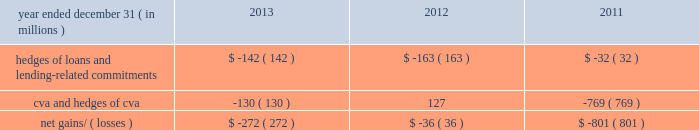Management 2019s discussion and analysis 138 jpmorgan chase & co./2013 annual report the credit derivatives used in credit portfolio management activities do not qualify for hedge accounting under u.s .
Gaap ; these derivatives are reported at fair value , with gains and losses recognized in principal transactions revenue .
In contrast , the loans and lending-related commitments being risk-managed are accounted for on an accrual basis .
This asymmetry in accounting treatment , between loans and lending-related commitments and the credit derivatives used in credit portfolio management activities , causes earnings volatility that is not representative , in the firm 2019s view , of the true changes in value of the firm 2019s overall credit exposure .
The effectiveness of the firm 2019s credit default swap ( 201ccds 201d ) protection as a hedge of the firm 2019s exposures may vary depending on a number of factors , including the named reference entity ( i.e. , the firm may experience losses on specific exposures that are different than the named reference entities in the purchased cds ) , and the contractual terms of the cds ( which may have a defined credit event that does not align with an actual loss realized by the firm ) and the maturity of the firm 2019s cds protection ( which in some cases may be shorter than the firm 2019s exposures ) .
However , the firm generally seeks to purchase credit protection with a maturity date that is the same or similar to the maturity date of the exposure for which the protection was purchased , and remaining differences in maturity are actively monitored and managed by the firm .
Credit portfolio hedges the table sets out the fair value related to the firm 2019s credit derivatives used in credit portfolio management activities , the fair value related to the cva ( which reflects the credit quality of derivatives counterparty exposure ) , as well as certain other hedges used in the risk management of cva .
These results can vary from period-to- period due to market conditions that affect specific positions in the portfolio .
Net gains and losses on credit portfolio hedges year ended december 31 , ( in millions ) 2013 2012 2011 hedges of loans and lending- related commitments $ ( 142 ) $ ( 163 ) $ ( 32 ) .
Community reinvestment act exposure the community reinvestment act ( 201ccra 201d ) encourages banks to meet the credit needs of borrowers in all segments of their communities , including neighborhoods with low or moderate incomes .
The firm is a national leader in community development by providing loans , investments and community development services in communities across the united states .
At december 31 , 2013 and 2012 , the firm 2019s cra loan portfolio was approximately $ 18 billion and $ 16 billion , respectively .
At december 31 , 2013 and 2012 , 50% ( 50 % ) and 62% ( 62 % ) , respectively , of the cra portfolio were residential mortgage loans ; 26% ( 26 % ) and 13% ( 13 % ) , respectively , were commercial real estate loans ; 16% ( 16 % ) and 18% ( 18 % ) , respectively , were business banking loans ; and 8% ( 8 % ) and 7% ( 7 % ) , respectively , were other loans .
Cra nonaccrual loans were 3% ( 3 % ) and 4% ( 4 % ) , respectively , of the firm 2019s total nonaccrual loans .
For the years ended december 31 , 2013 and 2012 , net charge-offs in the cra portfolio were 1% ( 1 % ) and 3% ( 3 % ) , respectively , of the firm 2019s net charge-offs in both years. .
At december 31 , 2013 what is the dollar amount of the cra loan portfolio that was not performing and charged off , in billions? 
Rationale: nonaccrual is assumed to be charged off
Computations: (18 * 3%)
Answer: 0.54. 